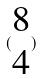<formula> <loc_0><loc_0><loc_500><loc_500>( \begin{matrix} 8 \\ 4 \end{matrix} )</formula> 